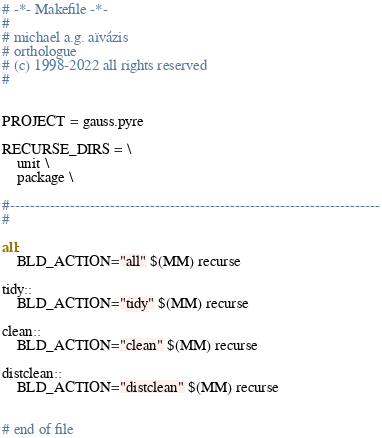<code> <loc_0><loc_0><loc_500><loc_500><_ObjectiveC_># -*- Makefile -*-
#
# michael a.g. aïvázis
# orthologue
# (c) 1998-2022 all rights reserved
#


PROJECT = gauss.pyre

RECURSE_DIRS = \
    unit \
    package \

#--------------------------------------------------------------------------
#

all:
	BLD_ACTION="all" $(MM) recurse

tidy::
	BLD_ACTION="tidy" $(MM) recurse

clean::
	BLD_ACTION="clean" $(MM) recurse

distclean::
	BLD_ACTION="distclean" $(MM) recurse


# end of file
</code> 